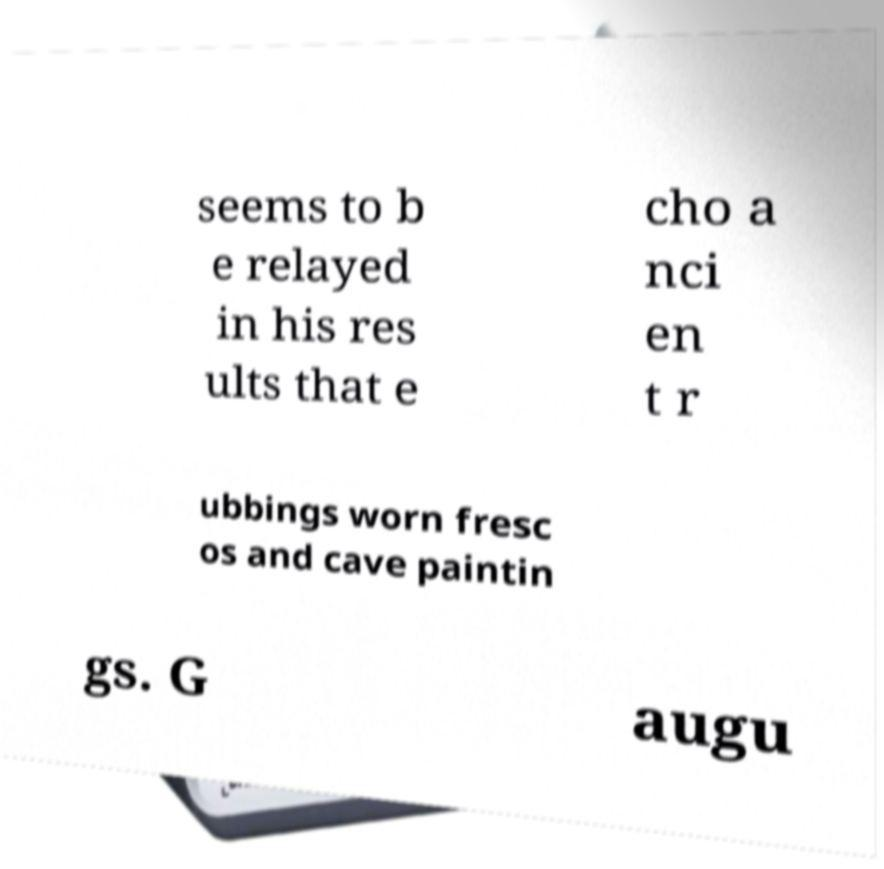Could you assist in decoding the text presented in this image and type it out clearly? seems to b e relayed in his res ults that e cho a nci en t r ubbings worn fresc os and cave paintin gs. G augu 